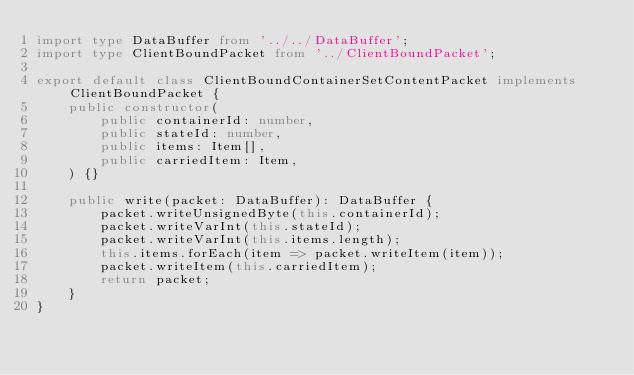<code> <loc_0><loc_0><loc_500><loc_500><_TypeScript_>import type DataBuffer from '../../DataBuffer';
import type ClientBoundPacket from '../ClientBoundPacket';

export default class ClientBoundContainerSetContentPacket implements ClientBoundPacket {
    public constructor(
        public containerId: number,
        public stateId: number,
        public items: Item[],
        public carriedItem: Item,
    ) {}

    public write(packet: DataBuffer): DataBuffer {
        packet.writeUnsignedByte(this.containerId);
        packet.writeVarInt(this.stateId);
        packet.writeVarInt(this.items.length);
        this.items.forEach(item => packet.writeItem(item));
        packet.writeItem(this.carriedItem);
        return packet;
    }
}
</code> 